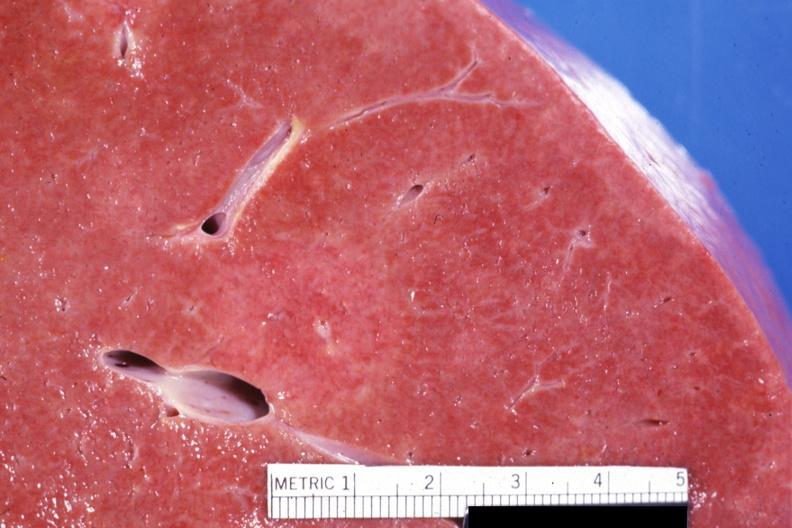how are this close-up of cut surface infiltrates?
Answer the question using a single word or phrase. Visible 